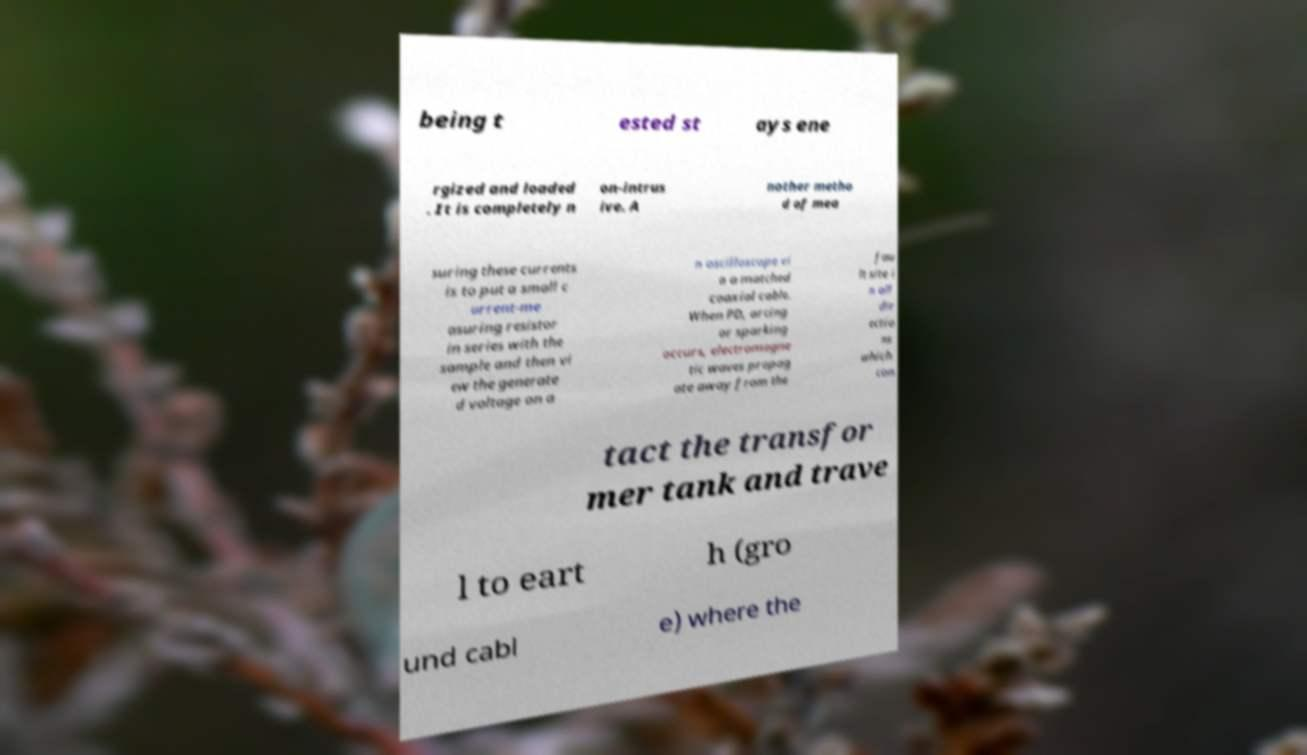Could you assist in decoding the text presented in this image and type it out clearly? being t ested st ays ene rgized and loaded . It is completely n on-intrus ive. A nother metho d of mea suring these currents is to put a small c urrent-me asuring resistor in series with the sample and then vi ew the generate d voltage on a n oscilloscope vi a a matched coaxial cable. When PD, arcing or sparking occurs, electromagne tic waves propag ate away from the fau lt site i n all dir ectio ns which con tact the transfor mer tank and trave l to eart h (gro und cabl e) where the 